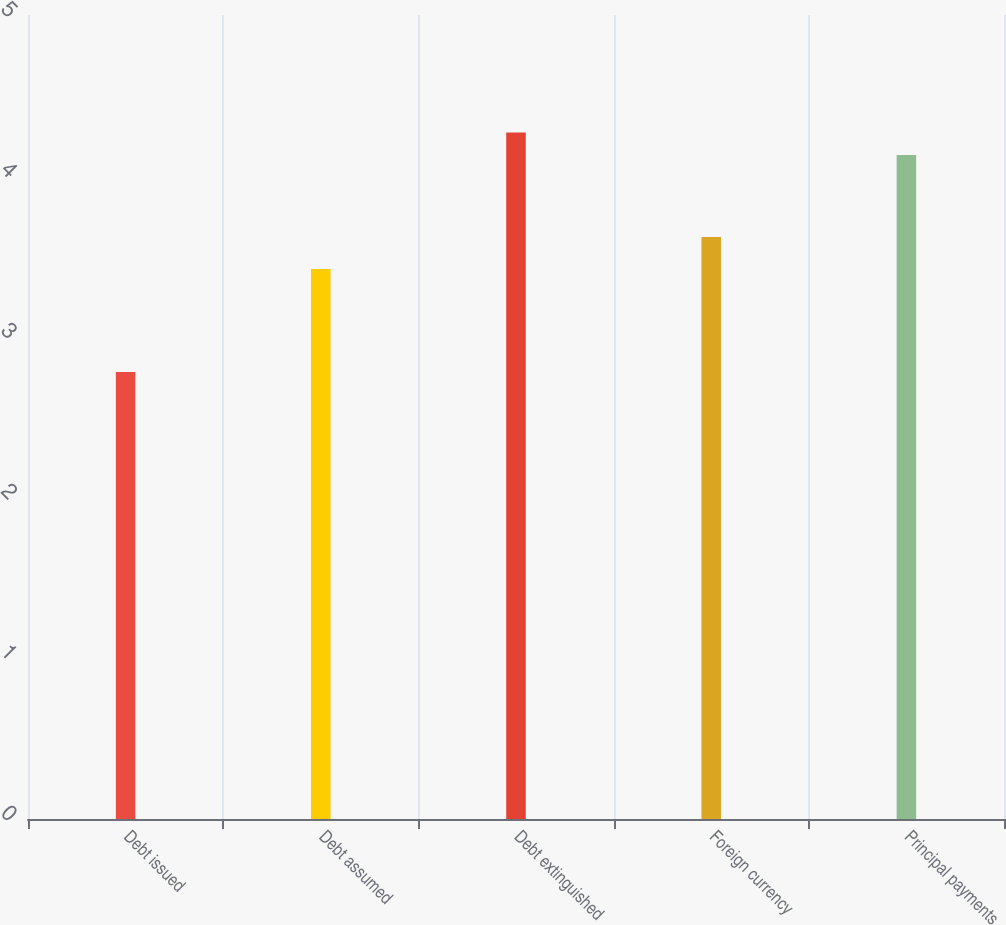<chart> <loc_0><loc_0><loc_500><loc_500><bar_chart><fcel>Debt issued<fcel>Debt assumed<fcel>Debt extinguished<fcel>Foreign currency<fcel>Principal payments<nl><fcel>2.78<fcel>3.42<fcel>4.27<fcel>3.62<fcel>4.13<nl></chart> 